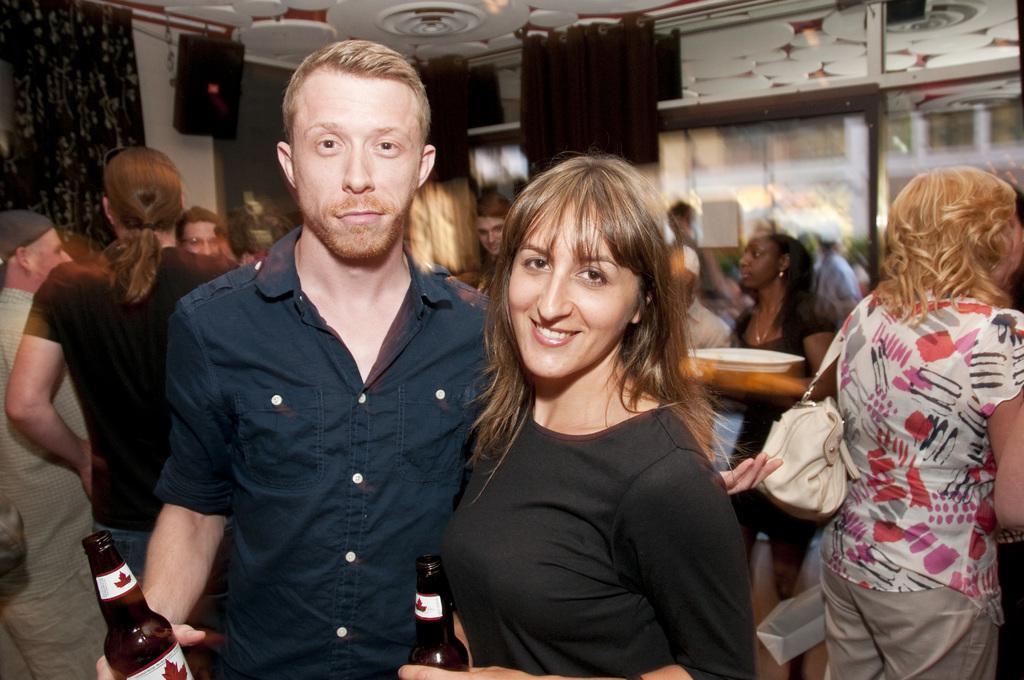Describe this image in one or two sentences. In this picture there are people, among them there are two people standing and holding bottles. In the background of the image we can see curtains, glass and objects, through this glass we can see people and it is blurry. At the top of the image we can see ceiling. 